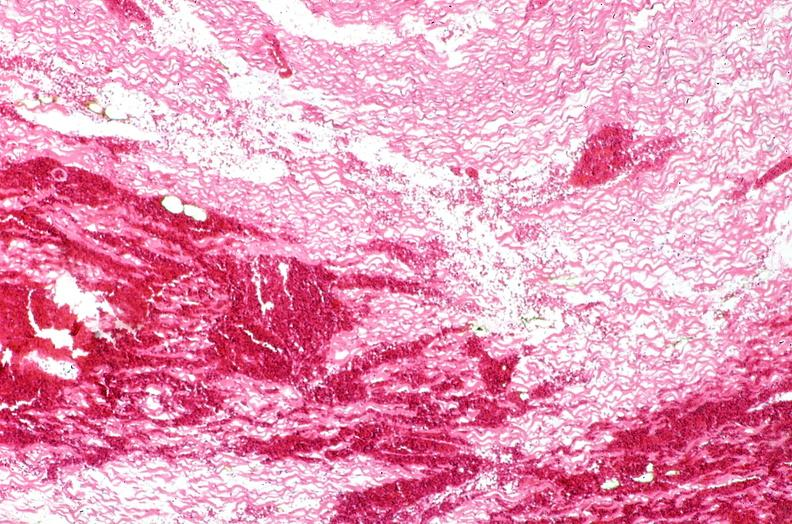s beckwith-wiedemann syndrome present?
Answer the question using a single word or phrase. No 